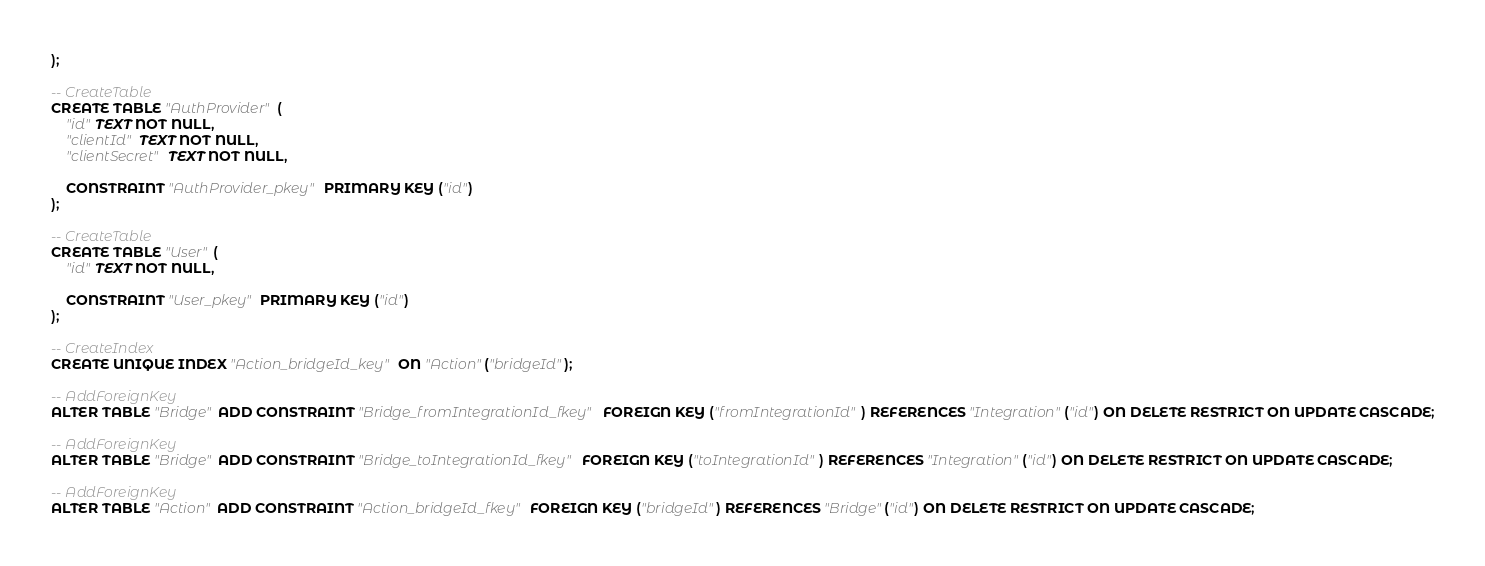<code> <loc_0><loc_0><loc_500><loc_500><_SQL_>);

-- CreateTable
CREATE TABLE "AuthProvider" (
    "id" TEXT NOT NULL,
    "clientId" TEXT NOT NULL,
    "clientSecret" TEXT NOT NULL,

    CONSTRAINT "AuthProvider_pkey" PRIMARY KEY ("id")
);

-- CreateTable
CREATE TABLE "User" (
    "id" TEXT NOT NULL,

    CONSTRAINT "User_pkey" PRIMARY KEY ("id")
);

-- CreateIndex
CREATE UNIQUE INDEX "Action_bridgeId_key" ON "Action"("bridgeId");

-- AddForeignKey
ALTER TABLE "Bridge" ADD CONSTRAINT "Bridge_fromIntegrationId_fkey" FOREIGN KEY ("fromIntegrationId") REFERENCES "Integration"("id") ON DELETE RESTRICT ON UPDATE CASCADE;

-- AddForeignKey
ALTER TABLE "Bridge" ADD CONSTRAINT "Bridge_toIntegrationId_fkey" FOREIGN KEY ("toIntegrationId") REFERENCES "Integration"("id") ON DELETE RESTRICT ON UPDATE CASCADE;

-- AddForeignKey
ALTER TABLE "Action" ADD CONSTRAINT "Action_bridgeId_fkey" FOREIGN KEY ("bridgeId") REFERENCES "Bridge"("id") ON DELETE RESTRICT ON UPDATE CASCADE;
</code> 